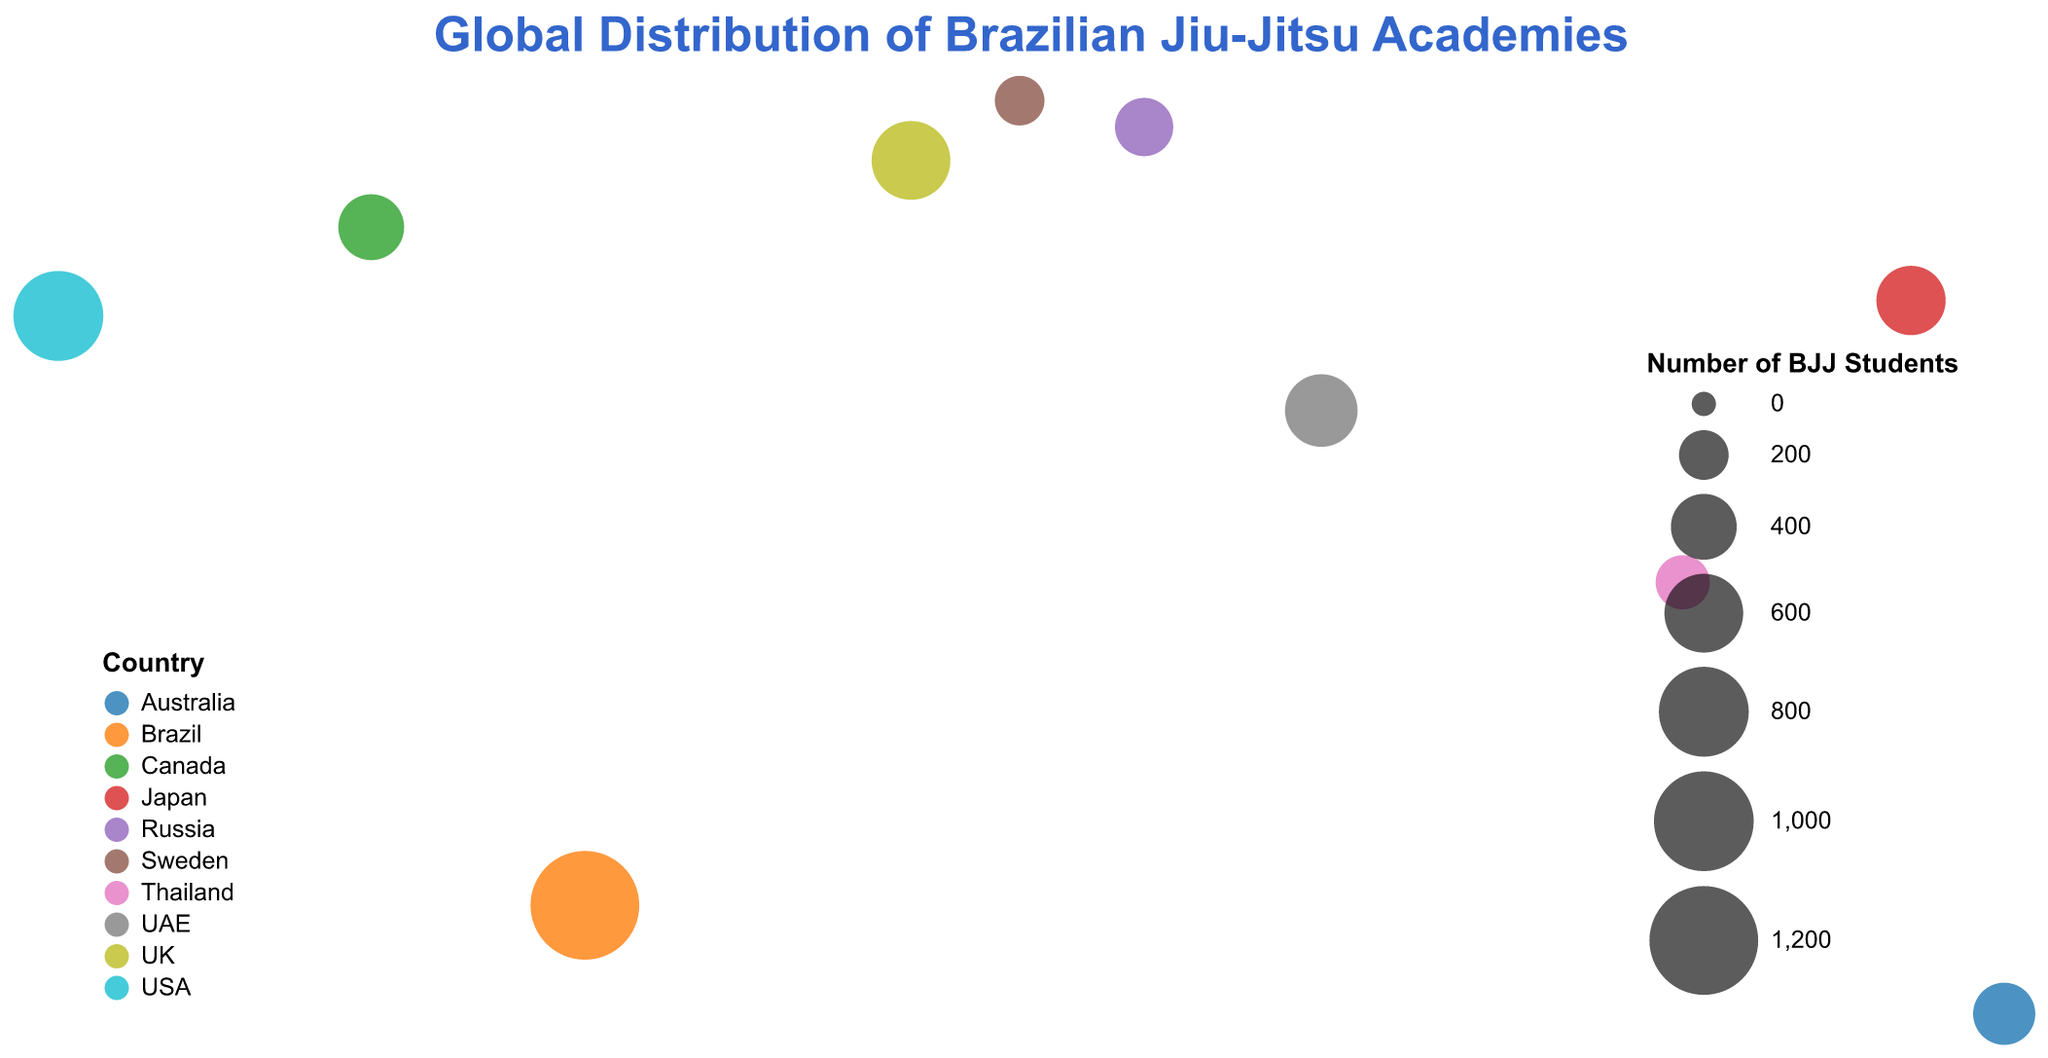What is the title of the figure? The title of the figure is displayed at the top and can be read directly. It typically summarizes the content visualized in a single sentence.
Answer: Global Distribution of Brazilian Jiu-Jitsu Academies How many Brazilian Jiu-Jitsu academies are included in the figure? Count the number of circle markers representing the academies on the map. Each marker corresponds to a different academy.
Answer: 10 Which country has the highest number of BJJ students in a single academy? Compare the sizes of the circle markers and refer to the legend indicating the number of BJJ students. The largest circle represents the highest number.
Answer: Brazil How many BJJ students are at Roger Gracie Academy in London? Hover over or refer to the tooltip of the circle marker located in London to see the number of BJJ students.
Answer: 600 What is the sum of BJJ students in academies located in Asia? Identify academies in Asia (Japan and UAE), then sum the number of BJJ students in these academies. Axis Jiu Jitsu Academy in Tokyo has 450 students, and ADCC Training Center in Abu Dhabi has 500 students.
Answer: 950 Which academy has more BJJ students: Rickson Gracie Jiu-Jitsu in Los Angeles or Toronto BJJ? Compare the number of BJJ students indicated in the tooltips for each academy. Rickson Gracie Jiu-Jitsu in Los Angeles has 800, and Toronto BJJ has 400.
Answer: Rickson Gracie Jiu-Jitsu What is the average number of BJJ students per academy across all academies in the figure? Sum the number of BJJ students from all academies and divide by the total number of academies (10). (1200 + 800 + 450 + 600 + 350 + 500 + 300 + 400 + 250 + 200) / 10 = 5050 / 10.
Answer: 505 Which continent has the most diverse spread of BJJ academies? Analyze the geographic spread of the circles across different continents to see where they are most widely distributed.
Answer: Different continents have academies, but overall spread can be visually assessed more in continents like Europe, Asia, Australia How many BJJ students are there in total, combining all the academies on the plot? Sum the BJJ students in all academies: 1200 + 800 + 450 + 600 + 350 + 500 + 300 + 400 + 250 + 200 = 5050.
Answer: 5050 Which two academies are the closest in terms of the number of BJJ students they have? Compare the sizes or check the exact numbers in the tooltips of all academies and find the smallest difference.
Answer: Toronto BJJ (400) and Axis Jiu Jitsu Academy (450) have the closest student numbers 